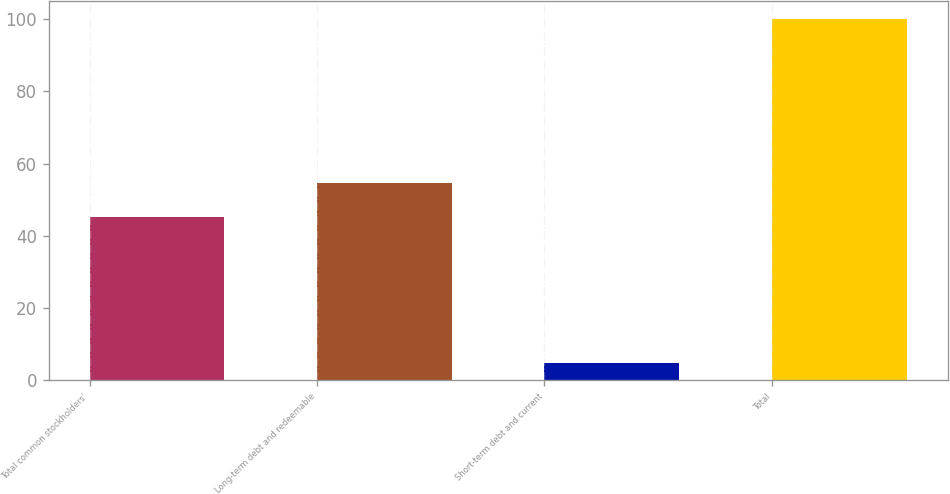Convert chart to OTSL. <chart><loc_0><loc_0><loc_500><loc_500><bar_chart><fcel>Total common stockholders'<fcel>Long-term debt and redeemable<fcel>Short-term debt and current<fcel>Total<nl><fcel>45.2<fcel>54.73<fcel>4.7<fcel>100<nl></chart> 